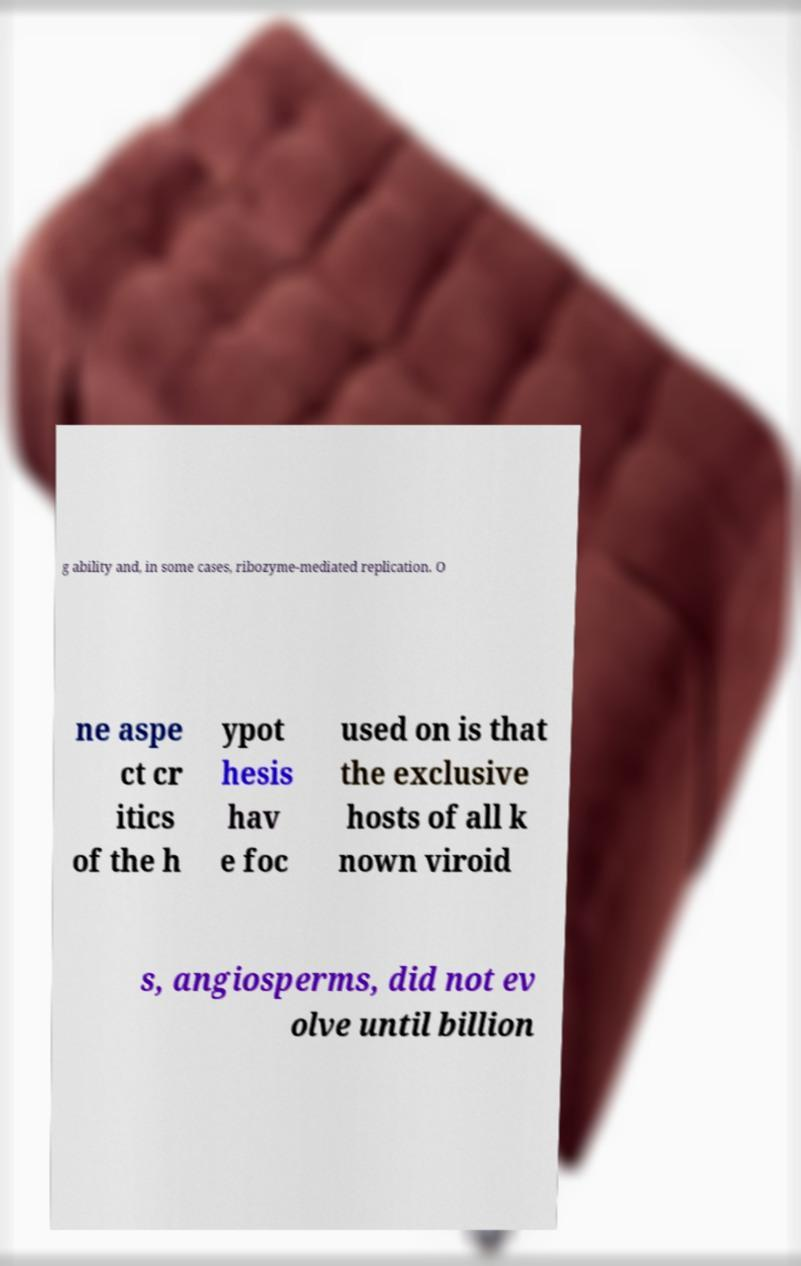Please identify and transcribe the text found in this image. g ability and, in some cases, ribozyme-mediated replication. O ne aspe ct cr itics of the h ypot hesis hav e foc used on is that the exclusive hosts of all k nown viroid s, angiosperms, did not ev olve until billion 